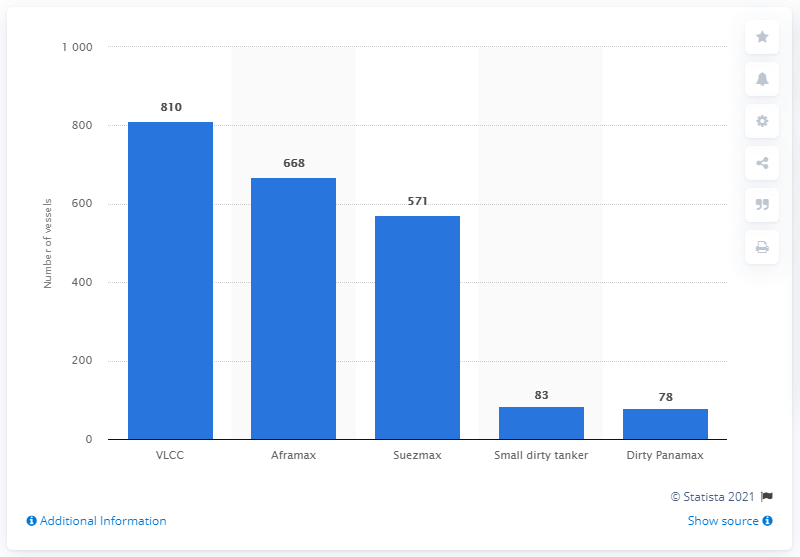List a handful of essential elements in this visual. As of April 2020, there were 810 very large crude carriers in existence. 